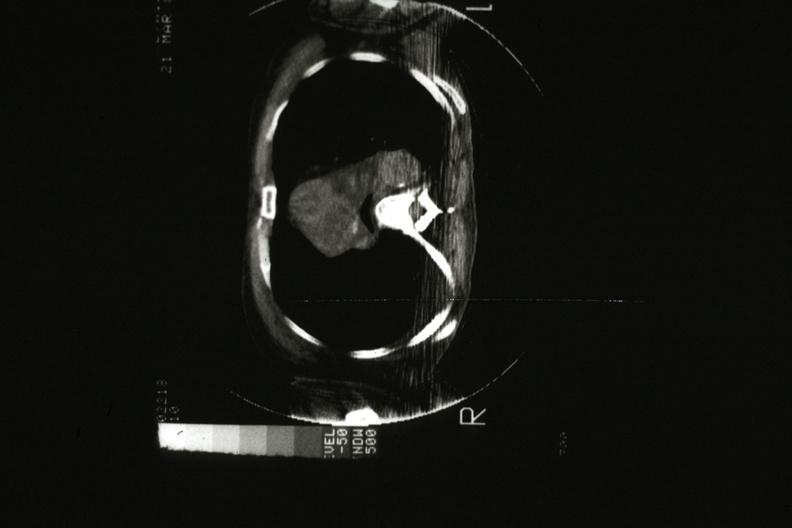what scan showing tumor mass invading superior vena ca?
Answer the question using a single word or phrase. Cat 